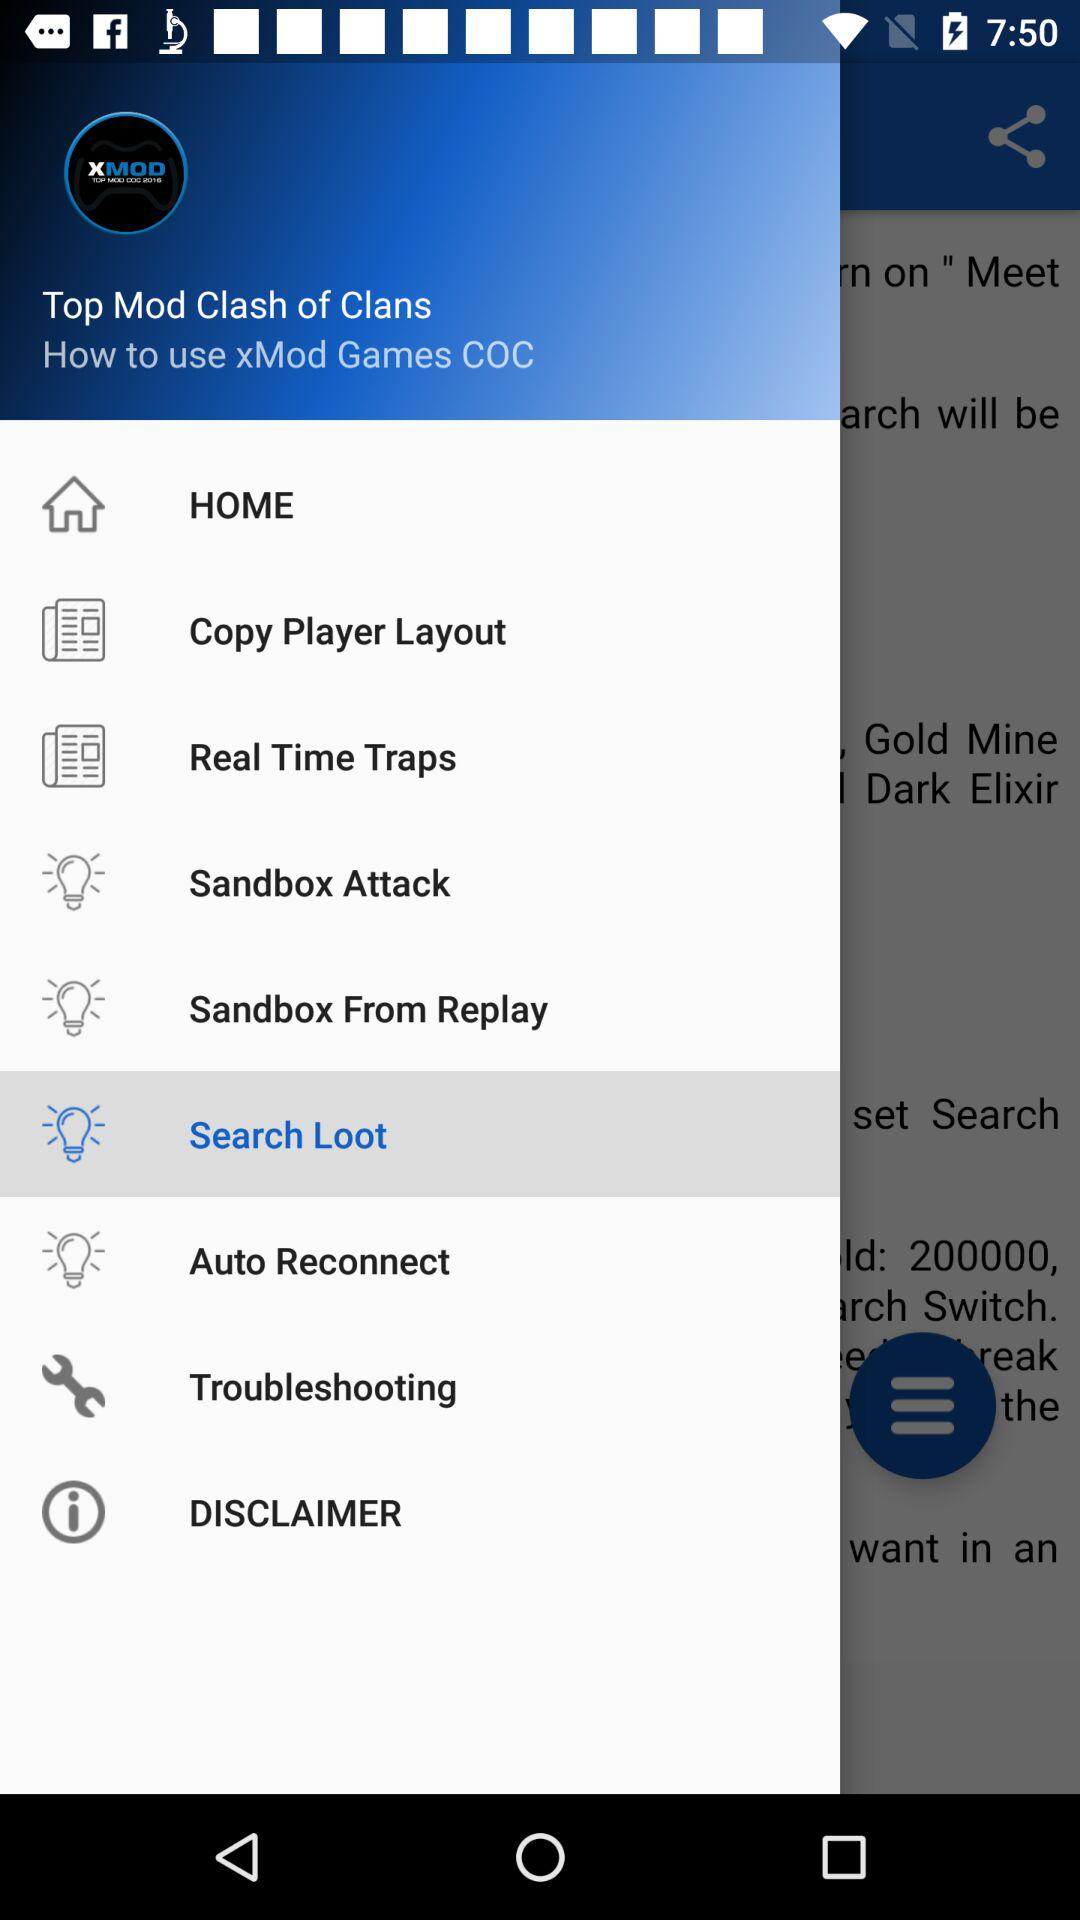What is the name of the application? The name of the application is "Clash of Clans". 